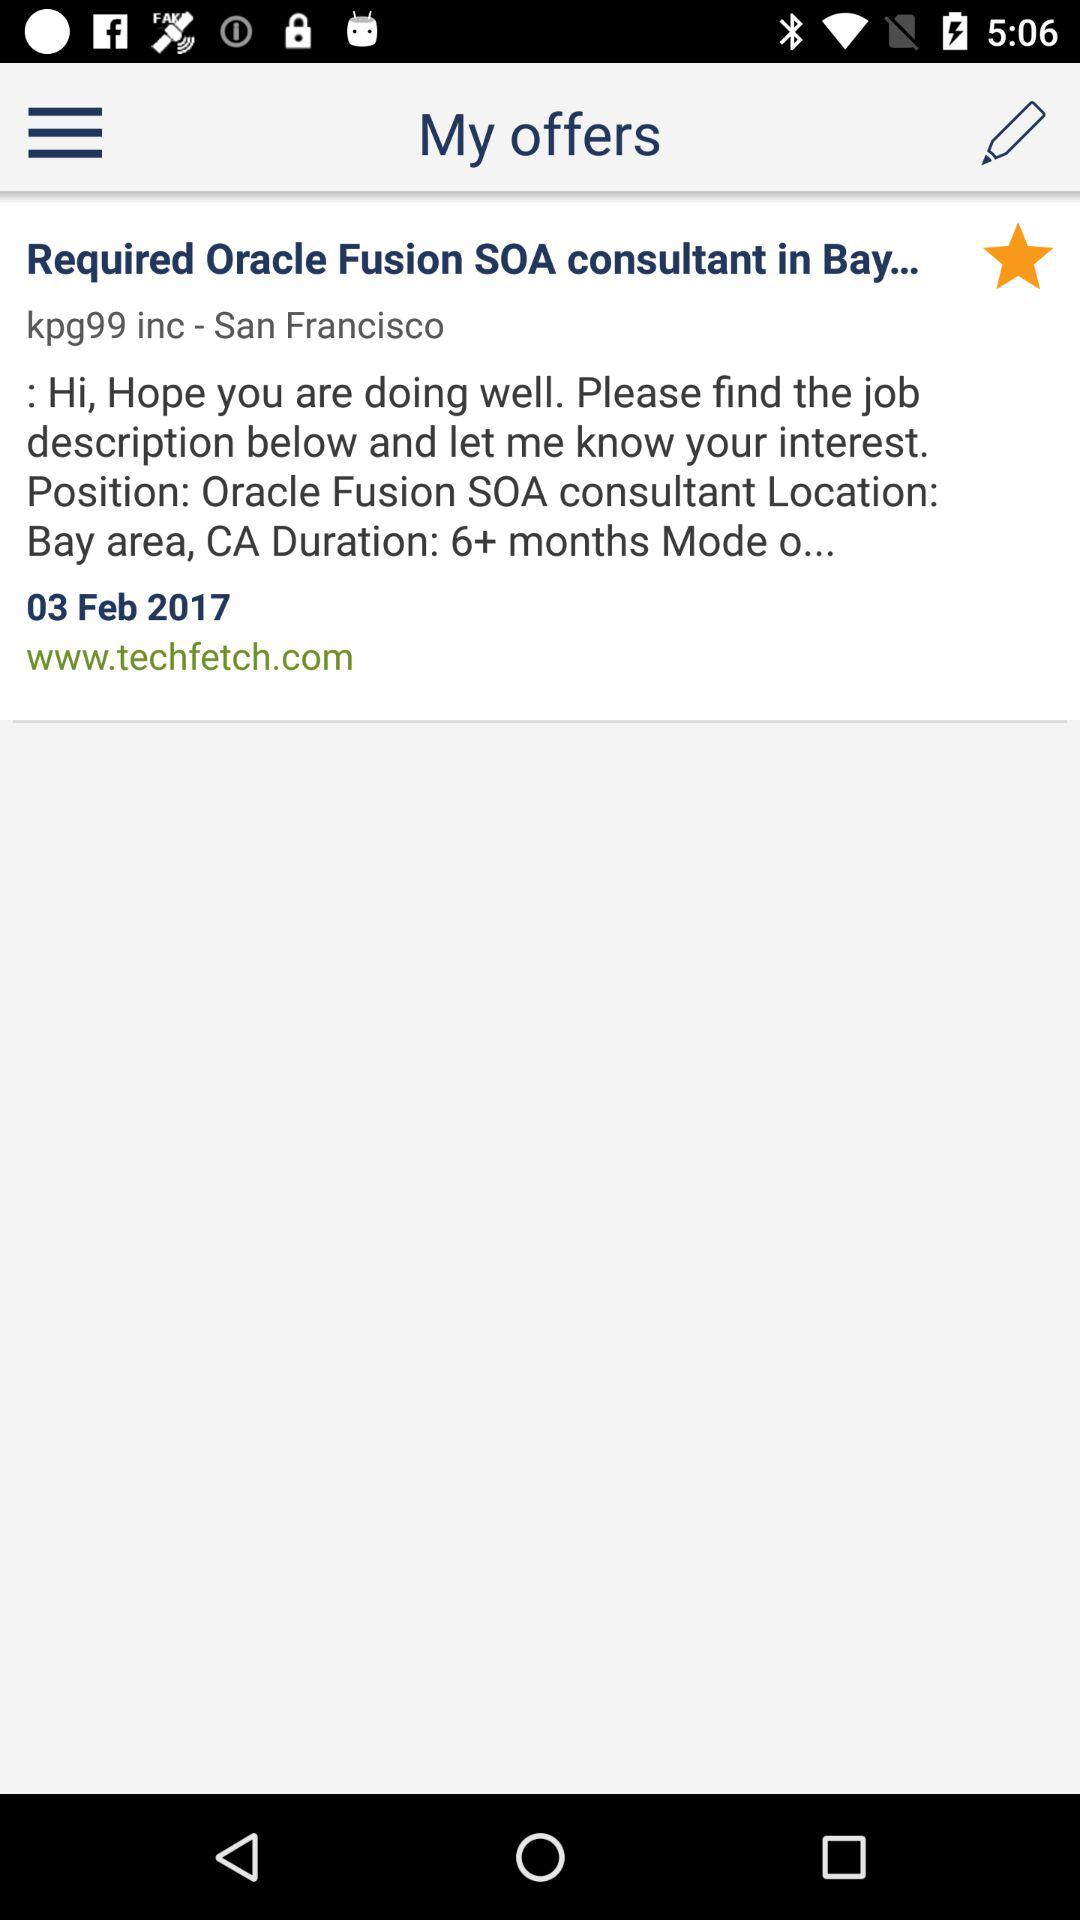What's the date? The date is February 3, 2017. 